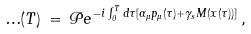<formula> <loc_0><loc_0><loc_500><loc_500>\Phi ( T ) \, = \, { \mathcal { P } } e ^ { - i \int _ { 0 } ^ { T } d \tau [ \alpha _ { \mu } p _ { \mu } ( \tau ) + \gamma _ { s } M ( x ( \tau ) ) ] } \, ,</formula> 